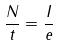Convert formula to latex. <formula><loc_0><loc_0><loc_500><loc_500>\frac { N } { t } = \frac { I } { e }</formula> 